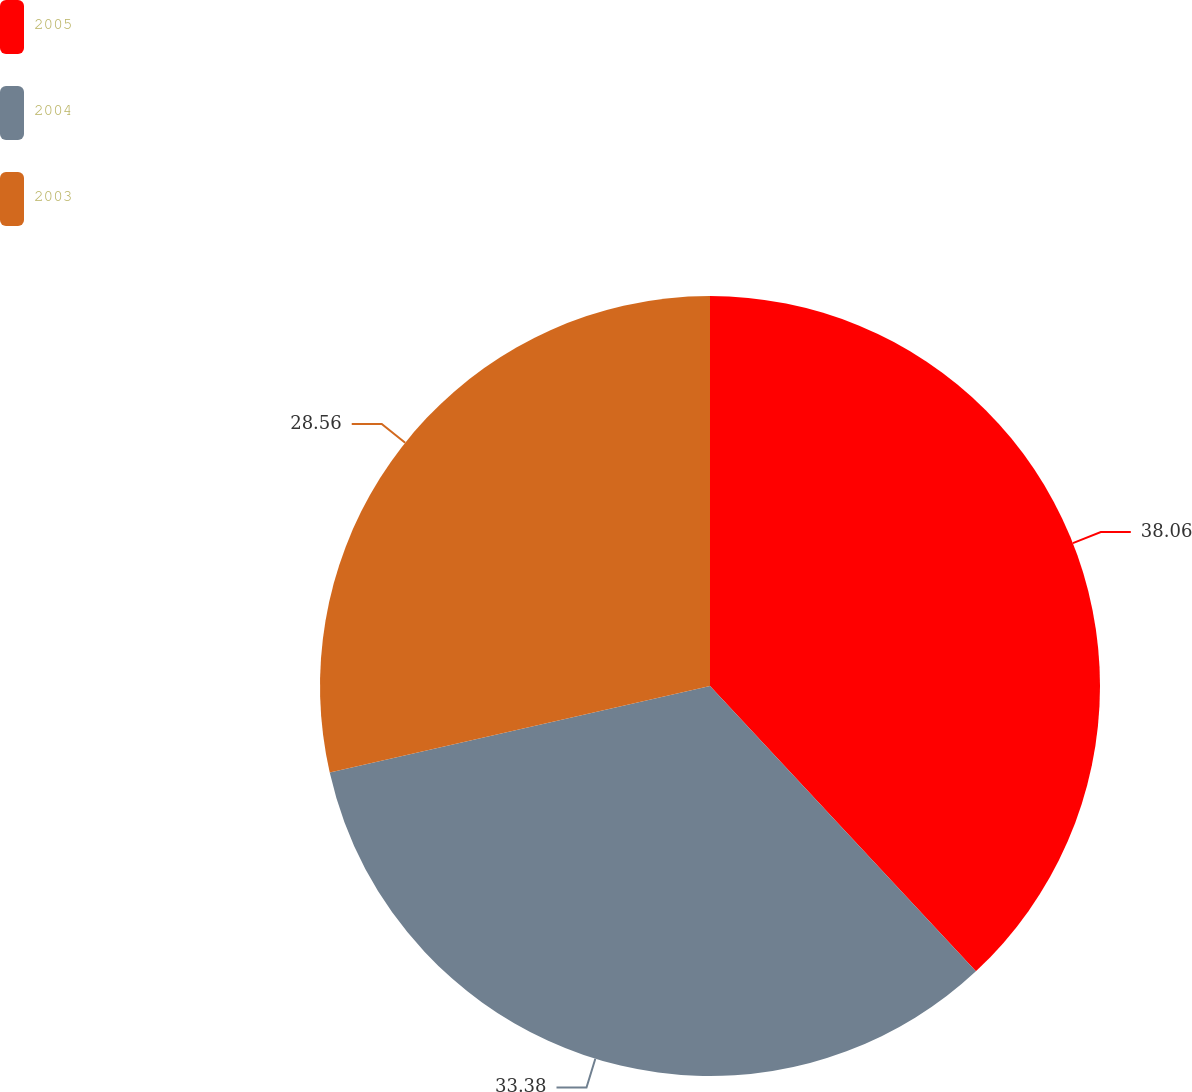Convert chart to OTSL. <chart><loc_0><loc_0><loc_500><loc_500><pie_chart><fcel>2005<fcel>2004<fcel>2003<nl><fcel>38.06%<fcel>33.38%<fcel>28.56%<nl></chart> 